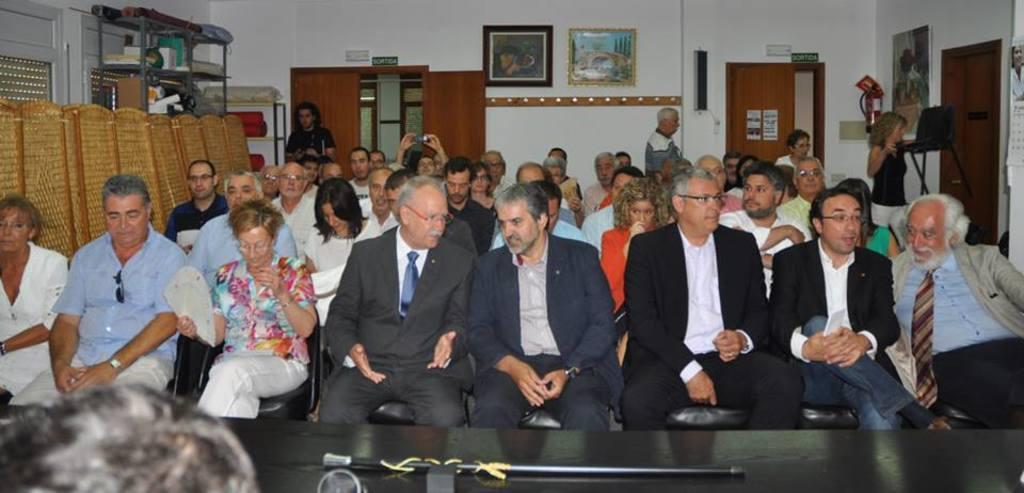Could you give a brief overview of what you see in this image? In this picture I can see few people seated on the chairs and few are standing in the back and I can see few photo frames on the wall and I can see a rack on the left side with few items in it and I can see a microphone and a man at the bottom of the picture and couple of posters on the door with some text and I can see fire extinguisher and a calendar on the wall. 